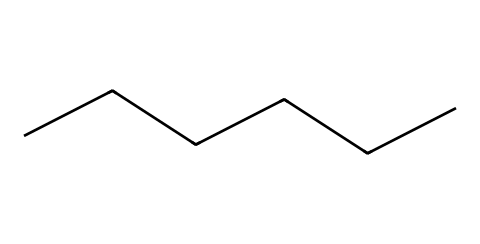What is the molecular formula of this chemical? The structural formula of hexane shows six carbon atoms and thirteen hydrogen atoms, thus the molecular formula is derived from counting these atoms.
Answer: C6H14 How many carbon atoms are present in this compound? The SMILES representation indicates a linear chain of six 'C' characters, each representing a carbon atom.
Answer: 6 What is the primary use of hexane in industries? Hexane is commonly used as a solvent in industrial degreasing processes due to its effectiveness in dissolving oils and fats.
Answer: degreasing Is hexane considered a polar or non-polar solvent? Given that hexane contains only carbon and hydrogen with a symmetrical structure, it is classified as a non-polar solvent due to the evenly distributed charge.
Answer: non-polar What type of chemical structure does hexane represent? Hexane exhibits an unbranched linear structure, which classifies it as a straight-chain alkane based on its saturated hydrocarbons.
Answer: alkane What is the boiling point of hexane? The boiling point of hexane can be referenced as being around approximately 68.7 degrees Celsius, a key property for its uses as a solvent.
Answer: 68.7 degrees Celsius 